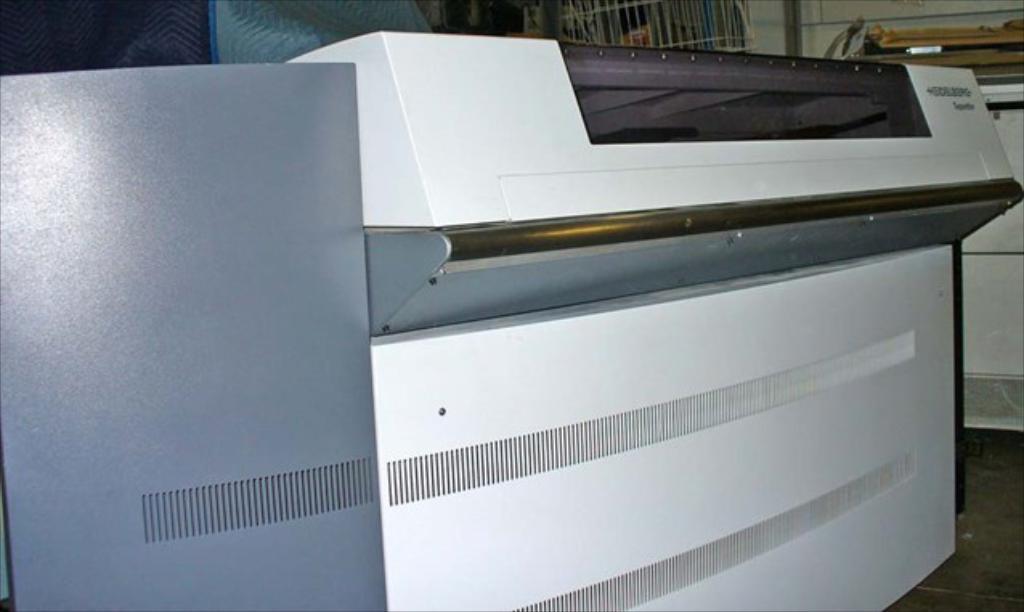In one or two sentences, can you explain what this image depicts? In this image we can see a machine, at the background, we can, there are some other objects on the floor. 